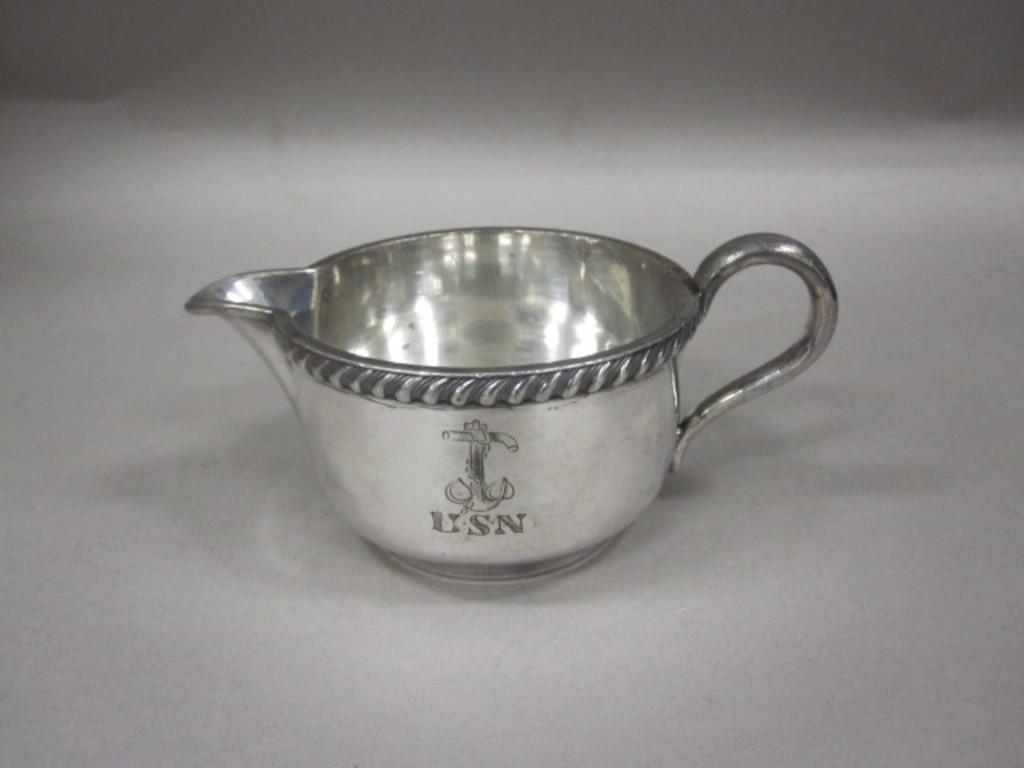Provide a one-sentence caption for the provided image. A silver tea cup of the USN sits on a surface. 